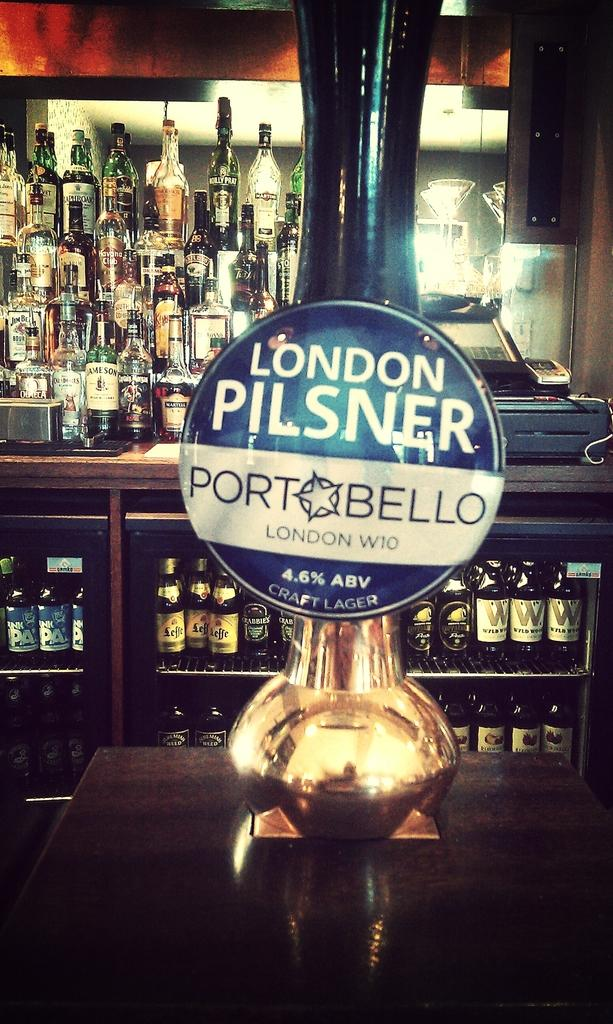<image>
Create a compact narrative representing the image presented. The brand of alcoholic drink is a London Pilsner 